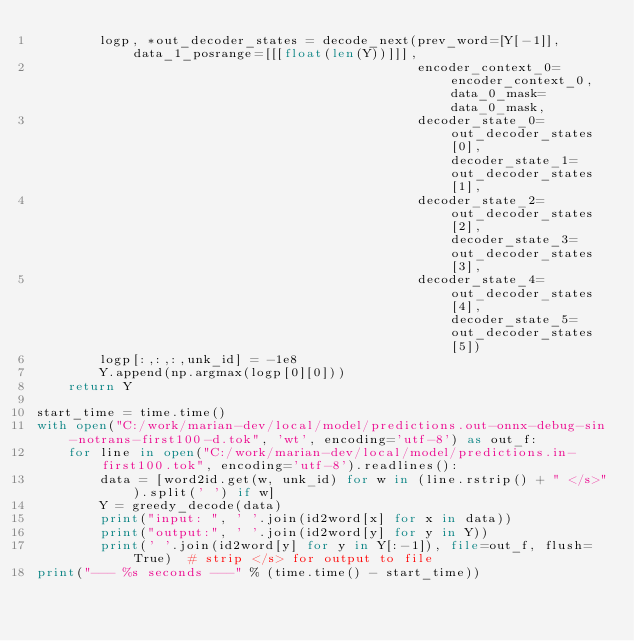<code> <loc_0><loc_0><loc_500><loc_500><_Python_>        logp, *out_decoder_states = decode_next(prev_word=[Y[-1]], data_1_posrange=[[[float(len(Y))]]],
                                                encoder_context_0=encoder_context_0, data_0_mask=data_0_mask,
                                                decoder_state_0=out_decoder_states[0], decoder_state_1=out_decoder_states[1],
                                                decoder_state_2=out_decoder_states[2], decoder_state_3=out_decoder_states[3],
                                                decoder_state_4=out_decoder_states[4], decoder_state_5=out_decoder_states[5])
        logp[:,:,:,unk_id] = -1e8
        Y.append(np.argmax(logp[0][0]))
    return Y

start_time = time.time()
with open("C:/work/marian-dev/local/model/predictions.out-onnx-debug-sin-notrans-first100-d.tok", 'wt', encoding='utf-8') as out_f:
    for line in open("C:/work/marian-dev/local/model/predictions.in-first100.tok", encoding='utf-8').readlines():
        data = [word2id.get(w, unk_id) for w in (line.rstrip() + " </s>").split(' ') if w]
        Y = greedy_decode(data)
        print("input: ", ' '.join(id2word[x] for x in data))
        print("output:", ' '.join(id2word[y] for y in Y))
        print(' '.join(id2word[y] for y in Y[:-1]), file=out_f, flush=True)  # strip </s> for output to file
print("--- %s seconds ---" % (time.time() - start_time))
</code> 